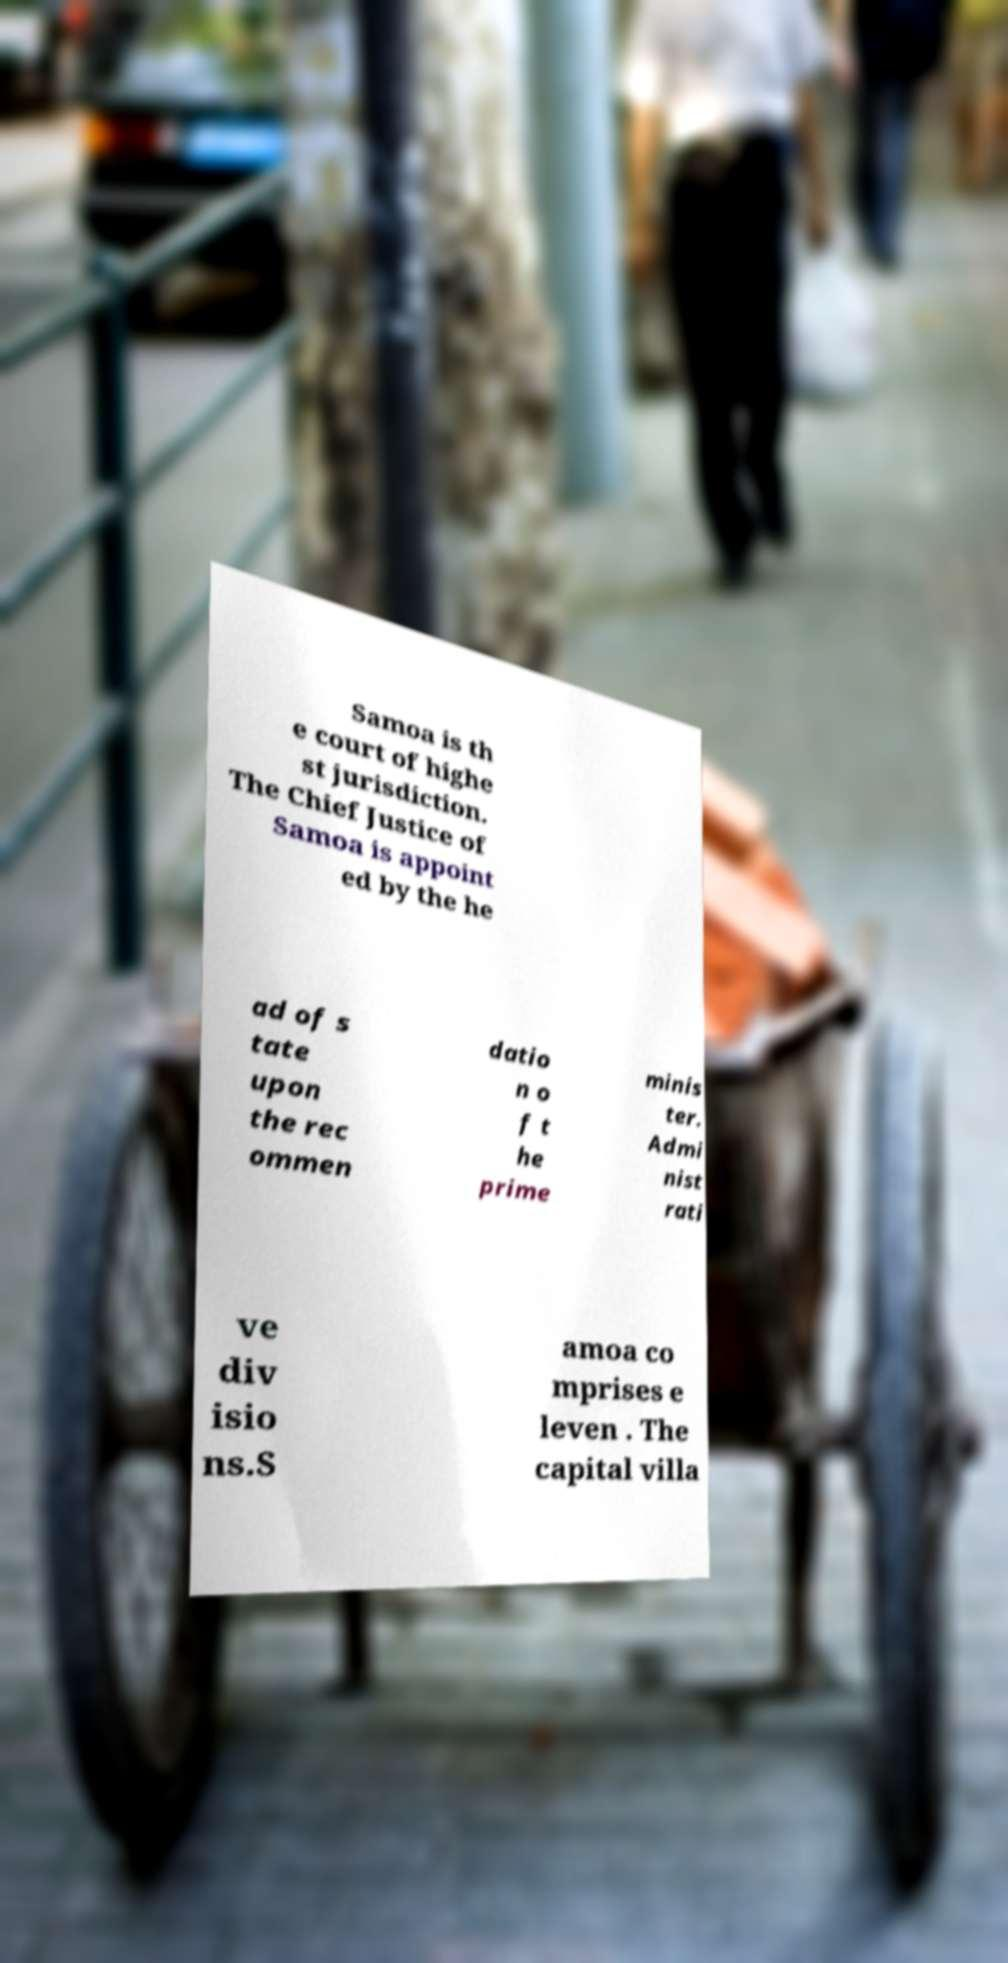Please read and relay the text visible in this image. What does it say? Samoa is th e court of highe st jurisdiction. The Chief Justice of Samoa is appoint ed by the he ad of s tate upon the rec ommen datio n o f t he prime minis ter. Admi nist rati ve div isio ns.S amoa co mprises e leven . The capital villa 